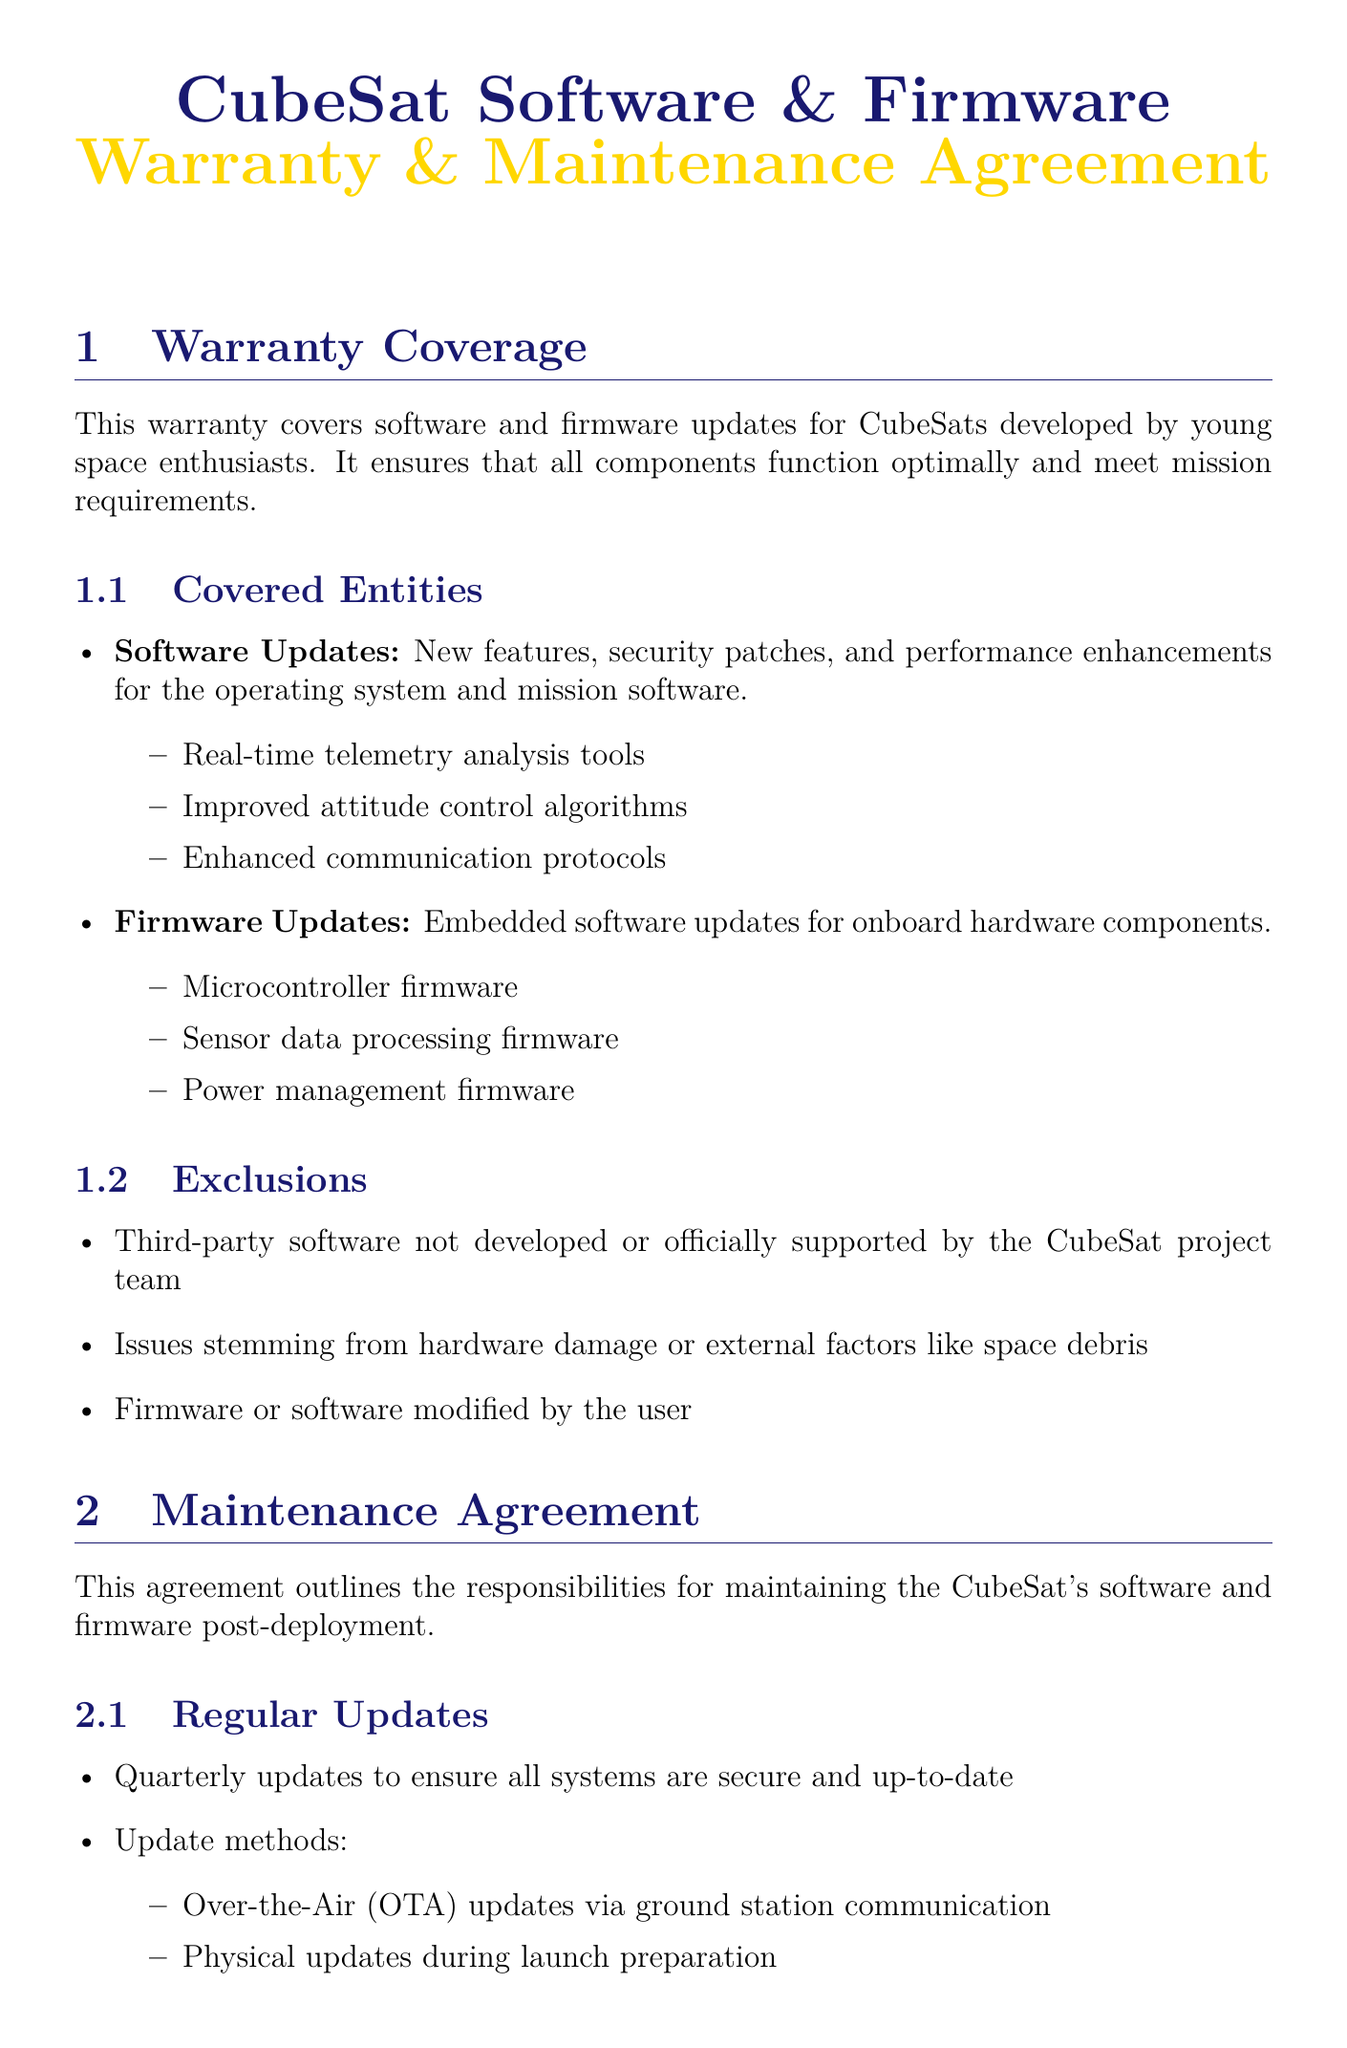What does the warranty cover? The warranty covers software and firmware updates for CubeSats developed by young space enthusiasts.
Answer: Software and firmware updates Who can benefit from the covered software updates? The covered software updates target the CubeSats developed by young space enthusiasts.
Answer: Young space enthusiasts What types of updates are included under firmware updates? Firmware updates include embedded software updates for onboard hardware components, such as microcontrollers and sensors.
Answer: Microcontroller firmware, sensor data processing firmware, power management firmware How often are regular updates scheduled? Regular updates are scheduled to maintain security and system functionality throughout the CubeSat's operation.
Answer: Quarterly What is the turnaround time for emergency patches? The turnaround time indicates how quickly urgent issues need to be identified and addressed during an emergency situation.
Answer: 24-hour What methods are used for regular updates? The document specifies the methods that can be employed to apply these updates to ensure effective firmware and software management.
Answer: Over-the-Air updates, physical updates What is excluded from the warranty coverage? The exclusions outline what is not covered under the warranty, which includes specific types of software and hardware issues.
Answer: Third-party software, hardware damage, modified firmware/software What type of support is provided for critical issues? Support services in the document refer to the help available to resolve urgent technical challenges faced by users.
Answer: 24/7 technical support 